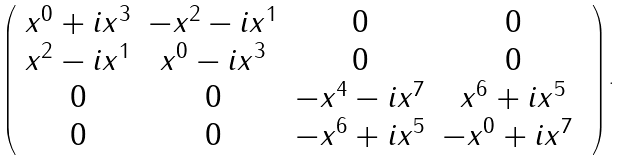<formula> <loc_0><loc_0><loc_500><loc_500>\left ( \begin{array} { c c c c } x ^ { 0 } + i x ^ { 3 } & - x ^ { 2 } - i x ^ { 1 } & 0 & 0 \\ x ^ { 2 } - i x ^ { 1 } & x ^ { 0 } - i x ^ { 3 } & 0 & 0 \\ 0 & 0 & - x ^ { 4 } - i x ^ { 7 } & x ^ { 6 } + i x ^ { 5 } \\ 0 & 0 & - x ^ { 6 } + i x ^ { 5 } & - x ^ { 0 } + i x ^ { 7 } \ \end{array} \right ) .</formula> 